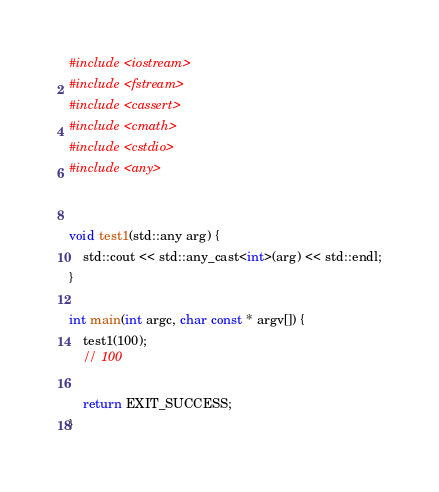Convert code to text. <code><loc_0><loc_0><loc_500><loc_500><_C++_>#include <iostream>
#include <fstream>
#include <cassert>
#include <cmath>
#include <cstdio>
#include <any>


void test1(std::any arg) {
    std::cout << std::any_cast<int>(arg) << std::endl;
}

int main(int argc, char const * argv[]) {
    test1(100);
    // 100

    return EXIT_SUCCESS;
}
</code> 